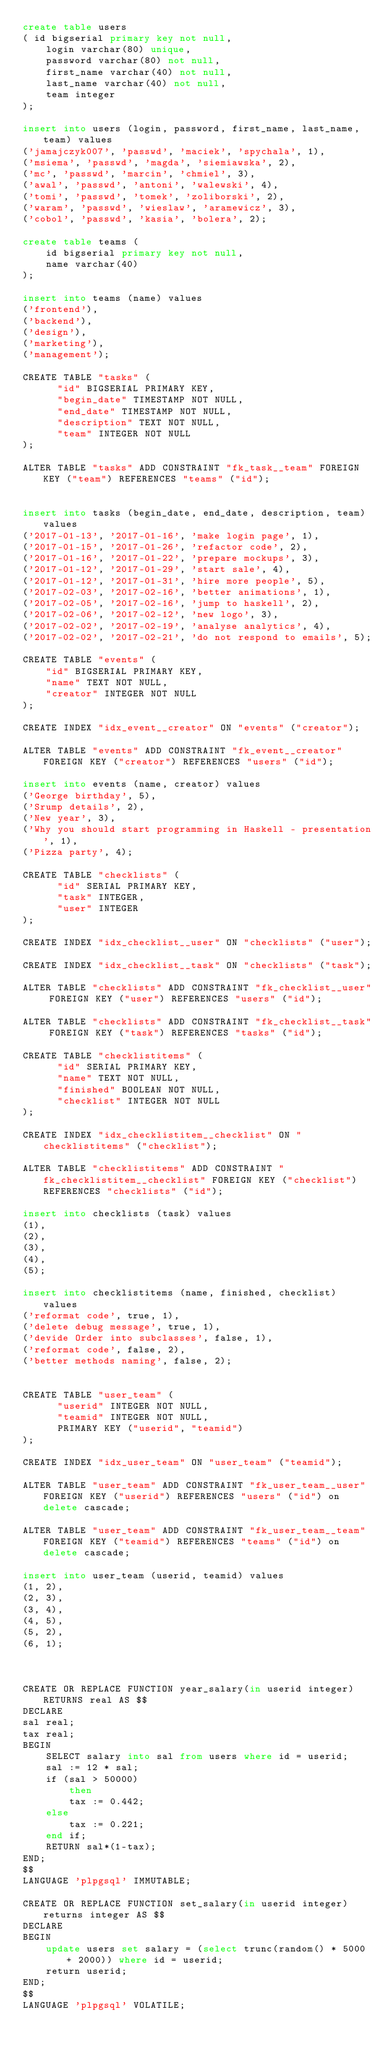Convert code to text. <code><loc_0><loc_0><loc_500><loc_500><_SQL_>create table users
( id bigserial primary key not null,
    login varchar(80) unique,
    password varchar(80) not null,
    first_name varchar(40) not null,
    last_name varchar(40) not null,
    team integer
);

insert into users (login, password, first_name, last_name, team) values
('jamajczyk007', 'passwd', 'maciek', 'spychala', 1),
('msiema', 'passwd', 'magda', 'siemiawska', 2),
('mc', 'passwd', 'marcin', 'chmiel', 3),
('awal', 'passwd', 'antoni', 'walewski', 4),
('tomi', 'passwd', 'tomek', 'zoliborski', 2),
('waram', 'passwd', 'wieslaw', 'aramewicz', 3),
('cobol', 'passwd', 'kasia', 'bolera', 2);

create table teams (
    id bigserial primary key not null,
    name varchar(40)
);

insert into teams (name) values
('frontend'),
('backend'),
('design'),
('marketing'),
('management');

CREATE TABLE "tasks" (
      "id" BIGSERIAL PRIMARY KEY,
      "begin_date" TIMESTAMP NOT NULL,
      "end_date" TIMESTAMP NOT NULL,
      "description" TEXT NOT NULL,
      "team" INTEGER NOT NULL
);

ALTER TABLE "tasks" ADD CONSTRAINT "fk_task__team" FOREIGN KEY ("team") REFERENCES "teams" ("id");


insert into tasks (begin_date, end_date, description, team) values
('2017-01-13', '2017-01-16', 'make login page', 1),
('2017-01-15', '2017-01-26', 'refactor code', 2),
('2017-01-16', '2017-01-22', 'prepare mockups', 3),
('2017-01-12', '2017-01-29', 'start sale', 4),
('2017-01-12', '2017-01-31', 'hire more people', 5),
('2017-02-03', '2017-02-16', 'better animations', 1),
('2017-02-05', '2017-02-16', 'jump to haskell', 2),
('2017-02-06', '2017-02-12', 'new logo', 3),
('2017-02-02', '2017-02-19', 'analyse analytics', 4),
('2017-02-02', '2017-02-21', 'do not respond to emails', 5);

CREATE TABLE "events" (
    "id" BIGSERIAL PRIMARY KEY,
    "name" TEXT NOT NULL,
    "creator" INTEGER NOT NULL
);

CREATE INDEX "idx_event__creator" ON "events" ("creator");

ALTER TABLE "events" ADD CONSTRAINT "fk_event__creator" FOREIGN KEY ("creator") REFERENCES "users" ("id");

insert into events (name, creator) values
('George birthday', 5),
('Srump details', 2),
('New year', 3),
('Why you should start programming in Haskell - presentation', 1),
('Pizza party', 4);

CREATE TABLE "checklists" (
      "id" SERIAL PRIMARY KEY,
      "task" INTEGER,
      "user" INTEGER
);

CREATE INDEX "idx_checklist__user" ON "checklists" ("user");

CREATE INDEX "idx_checklist__task" ON "checklists" ("task");

ALTER TABLE "checklists" ADD CONSTRAINT "fk_checklist__user" FOREIGN KEY ("user") REFERENCES "users" ("id");

ALTER TABLE "checklists" ADD CONSTRAINT "fk_checklist__task" FOREIGN KEY ("task") REFERENCES "tasks" ("id");

CREATE TABLE "checklistitems" (
      "id" SERIAL PRIMARY KEY,
      "name" TEXT NOT NULL,
      "finished" BOOLEAN NOT NULL,
      "checklist" INTEGER NOT NULL
);

CREATE INDEX "idx_checklistitem__checklist" ON "checklistitems" ("checklist");

ALTER TABLE "checklistitems" ADD CONSTRAINT "fk_checklistitem__checklist" FOREIGN KEY ("checklist") REFERENCES "checklists" ("id");

insert into checklists (task) values
(1),
(2),
(3),
(4),
(5);

insert into checklistitems (name, finished, checklist) values
('reformat code', true, 1),
('delete debug message', true, 1),
('devide Order into subclasses', false, 1),
('reformat code', false, 2),
('better methods naming', false, 2);


CREATE TABLE "user_team" (
      "userid" INTEGER NOT NULL,
      "teamid" INTEGER NOT NULL,
      PRIMARY KEY ("userid", "teamid")
);

CREATE INDEX "idx_user_team" ON "user_team" ("teamid");

ALTER TABLE "user_team" ADD CONSTRAINT "fk_user_team__user" FOREIGN KEY ("userid") REFERENCES "users" ("id") on delete cascade;

ALTER TABLE "user_team" ADD CONSTRAINT "fk_user_team__team" FOREIGN KEY ("teamid") REFERENCES "teams" ("id") on delete cascade;

insert into user_team (userid, teamid) values
(1, 2),
(2, 3),
(3, 4),
(4, 5),
(5, 2),
(6, 1);



CREATE OR REPLACE FUNCTION year_salary(in userid integer) RETURNS real AS $$
DECLARE
sal real;
tax real;
BEGIN
    SELECT salary into sal from users where id = userid;
    sal := 12 * sal;
    if (sal > 50000)
        then 
        tax := 0.442;
    else
        tax := 0.221;
    end if; 
    RETURN sal*(1-tax);
END;
$$
LANGUAGE 'plpgsql' IMMUTABLE;

CREATE OR REPLACE FUNCTION set_salary(in userid integer) returns integer AS $$
DECLARE
BEGIN
    update users set salary = (select trunc(random() * 5000 + 2000)) where id = userid;
    return userid;
END;
$$
LANGUAGE 'plpgsql' VOLATILE;
</code> 